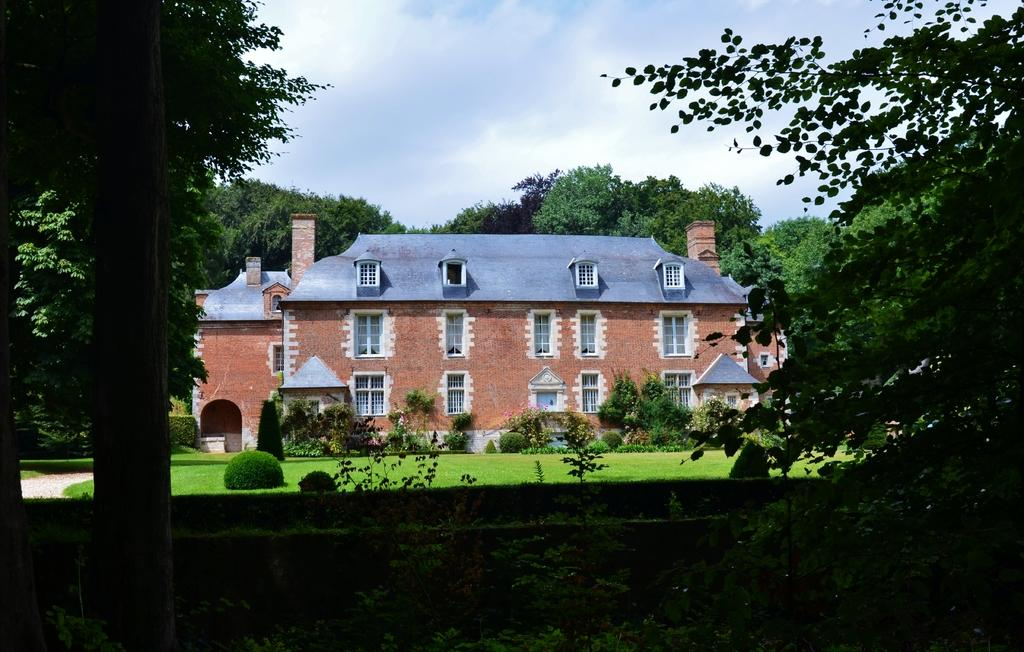What type of structure is in the image? There is a building in the image. What feature can be seen on the building? The building has windows. What type of vegetation is around the building? Trees are present around the building. What type of ground cover is visible in the image? There is grass visible in the image. What type of living organisms are present in the image? Plants are present in the image. What is the condition of the sky in the image? The sky is cloudy in the image. What type of kitten can be seen playing in the downtown area in the image? There is no kitten or downtown area present in the image; it features a building with trees and grass around it. What type of amusement park can be seen in the background of the image? There is no amusement park visible in the image; it only shows a building with trees, grass, and a cloudy sky. 